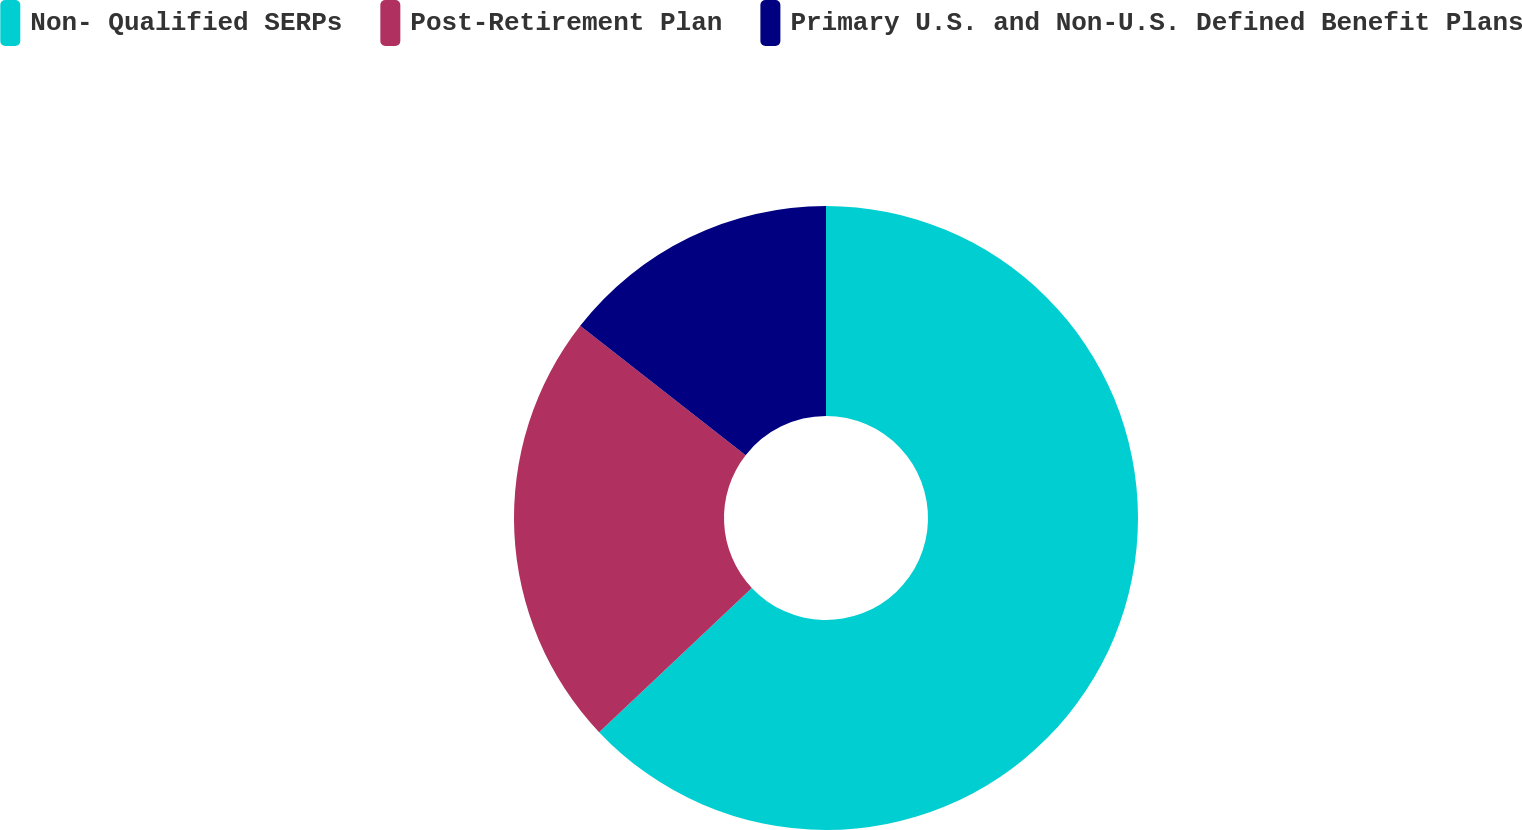Convert chart to OTSL. <chart><loc_0><loc_0><loc_500><loc_500><pie_chart><fcel>Non- Qualified SERPs<fcel>Post-Retirement Plan<fcel>Primary U.S. and Non-U.S. Defined Benefit Plans<nl><fcel>62.96%<fcel>22.6%<fcel>14.44%<nl></chart> 